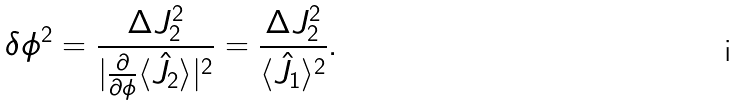<formula> <loc_0><loc_0><loc_500><loc_500>\delta \phi ^ { 2 } = \frac { \Delta J _ { 2 } ^ { 2 } } { | \frac { \partial } { \partial \phi } \langle \hat { J } _ { 2 } \rangle | ^ { 2 } } = \frac { \Delta J _ { 2 } ^ { 2 } } { \langle \hat { J } _ { 1 } \rangle ^ { 2 } } .</formula> 